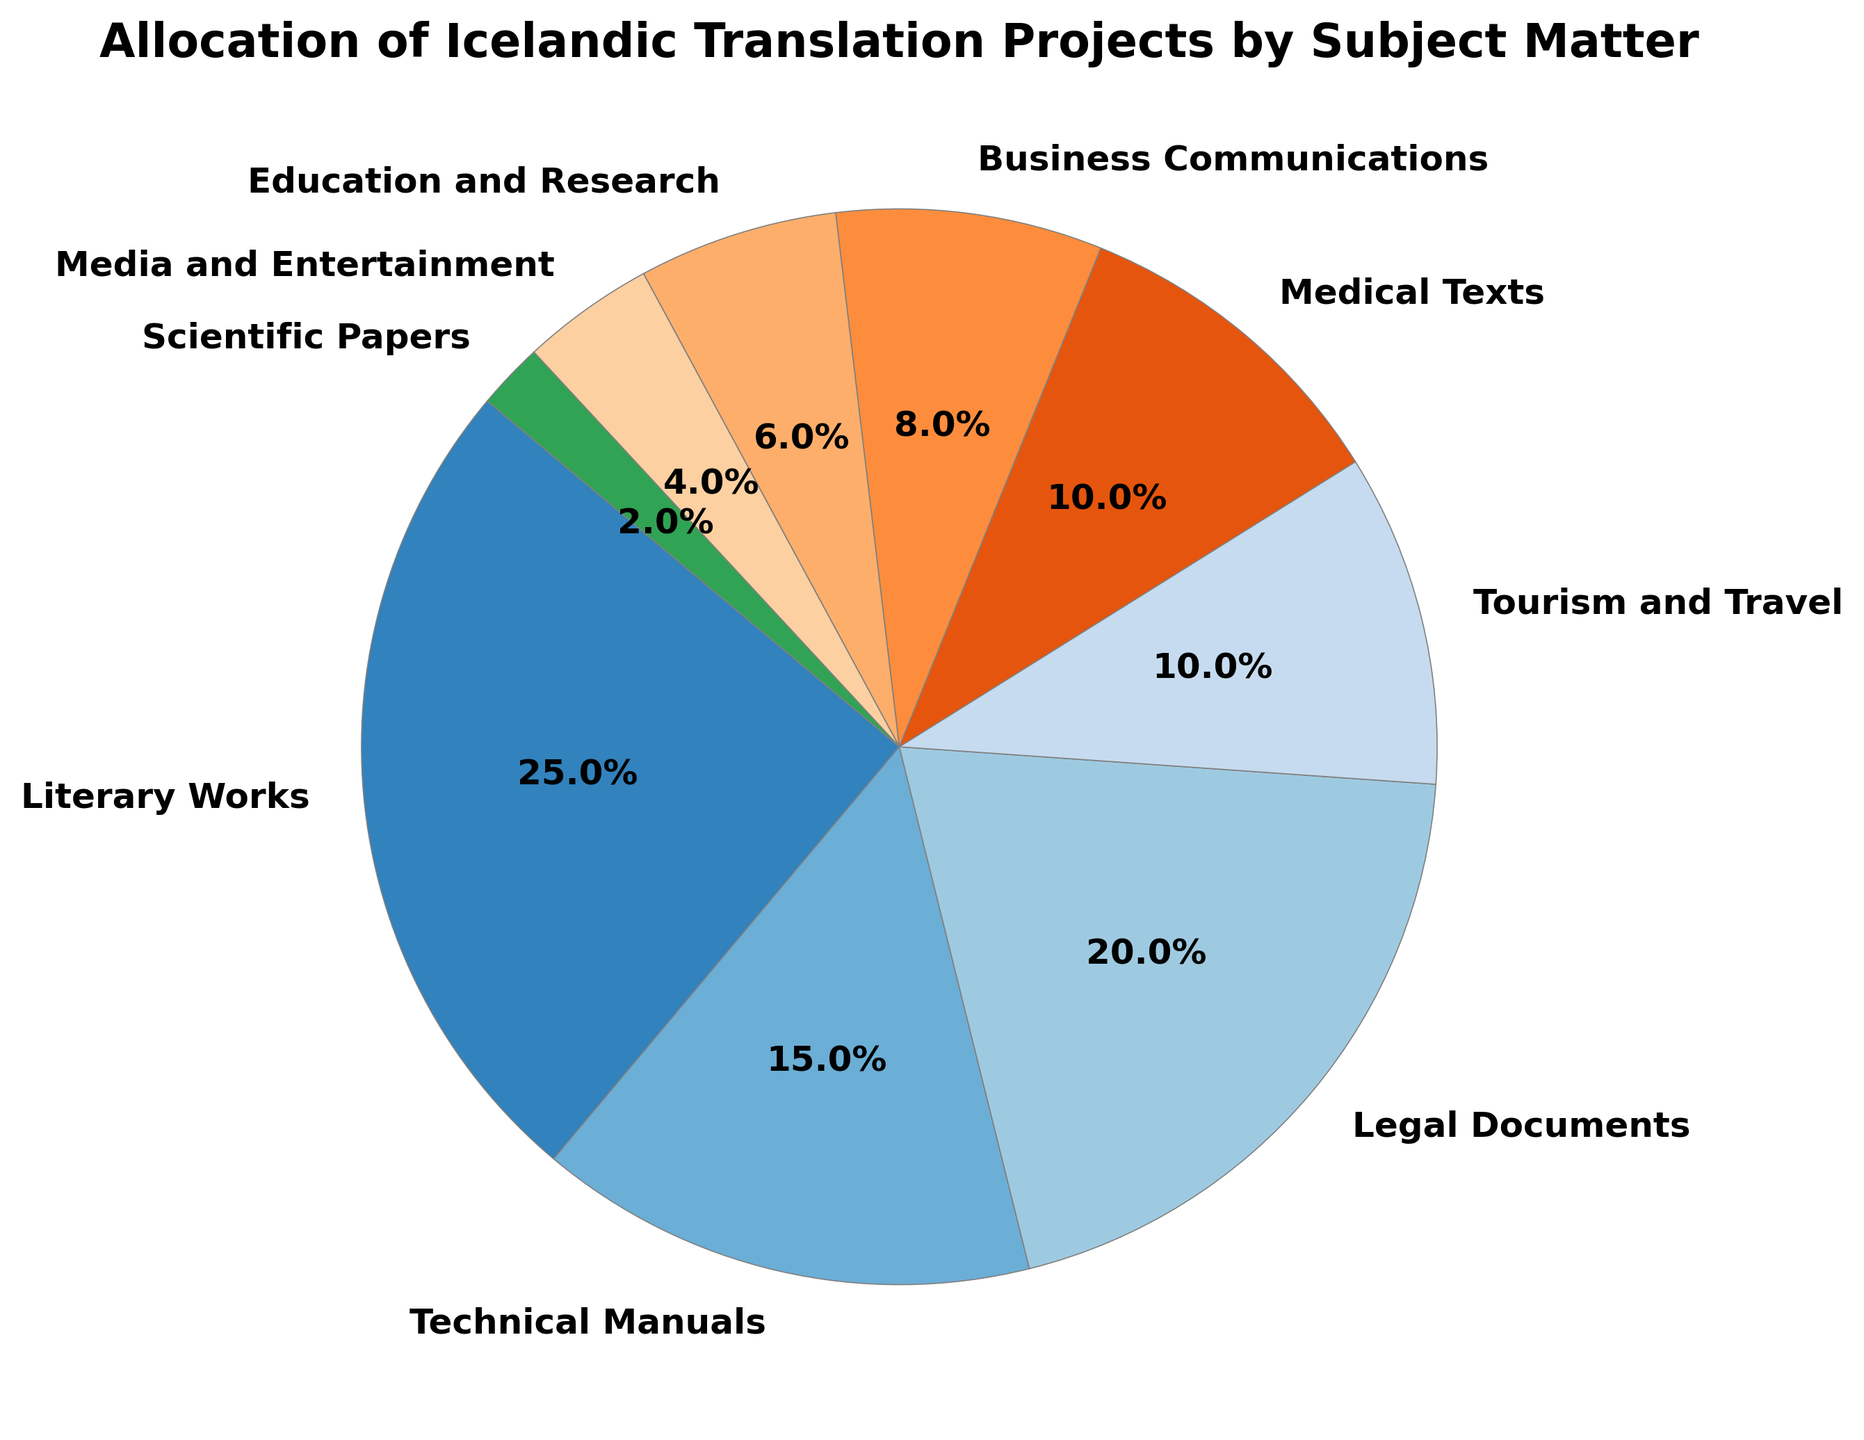Which subject matter has the largest allocation percentage? Identify the slice with the largest percentage label on the pie chart. In this case, it's 'Literary Works' with 25%.
Answer: Literary Works Which subject matter has the smallest allocation percentage? Identify the slice with the smallest percentage label on the pie chart. This is 'Scientific Papers' with 2%.
Answer: Scientific Papers What is the combined allocation percentage of 'Medical Texts' and 'Tourism and Travel'? Find the slices labeled 'Medical Texts' and 'Tourism and Travel', then add their percentages: 10% + 10% = 20%.
Answer: 20% How much larger is the allocation for 'Technical Manuals' compared to 'Media and Entertainment'? Subtract the percentage of 'Media and Entertainment' from 'Technical Manuals': 15% - 4% = 11%.
Answer: 11% Is the allocation percentage for 'Legal Documents' higher than 'Business Communications'? Compare the percentages: 'Legal Documents' has 20%, while 'Business Communications' has 8%. Since 20% is greater than 8%, the answer is yes.
Answer: Yes Which subjects have an allocation percentage of exactly 10%? Locate slices on the pie chart with labels showing 10%. Both 'Medical Texts' and 'Tourism and Travel' have 10%.
Answer: Medical Texts, Tourism and Travel What are the subjects with an allocation percentage exceeding 15%? Identify slices where the percentage is over 15%. This includes 'Literary Works' (25%) and 'Legal Documents' (20%).
Answer: Literary Works, Legal Documents What is the difference between the allocation percentages for 'Education and Research' and 'Business Communications'? Subtract the allocation of 'Education and Research' from 'Business Communications': 8% - 6% = 2%.
Answer: 2% What is the average allocation percentage of 'Literary Works', 'Technical Manuals', and 'Legal Documents'? Sum their percentages: 25% + 15% + 20% = 60%. Divide by the number of subjects: 60% / 3 = 20%.
Answer: 20% How much more allocation does 'Tourism and Travel' receive than 'Scientific Papers'? Subtract the percentage of 'Scientific Papers' from 'Tourism and Travel': 10% - 2% = 8%.
Answer: 8% 